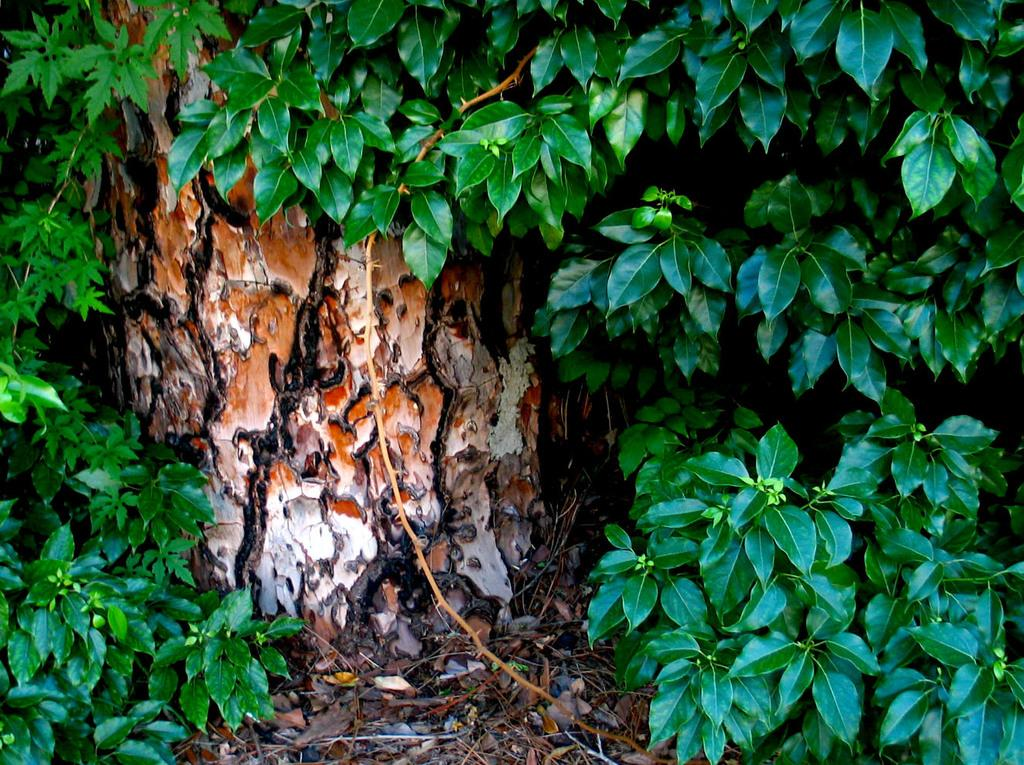What is located in the foreground of the image? There are plants in the foreground of the image. What can be seen in the background of the image? There is a trunk in the background of the image. What type of natural material is present at the bottom side of the image? Dry leaves are present at the bottom side of the image. What type of peace is being negotiated in the image? There is no indication of any peace negotiations or discussions in the image. How much debt is visible in the image? There is no mention of debt or financial matters in the image. 